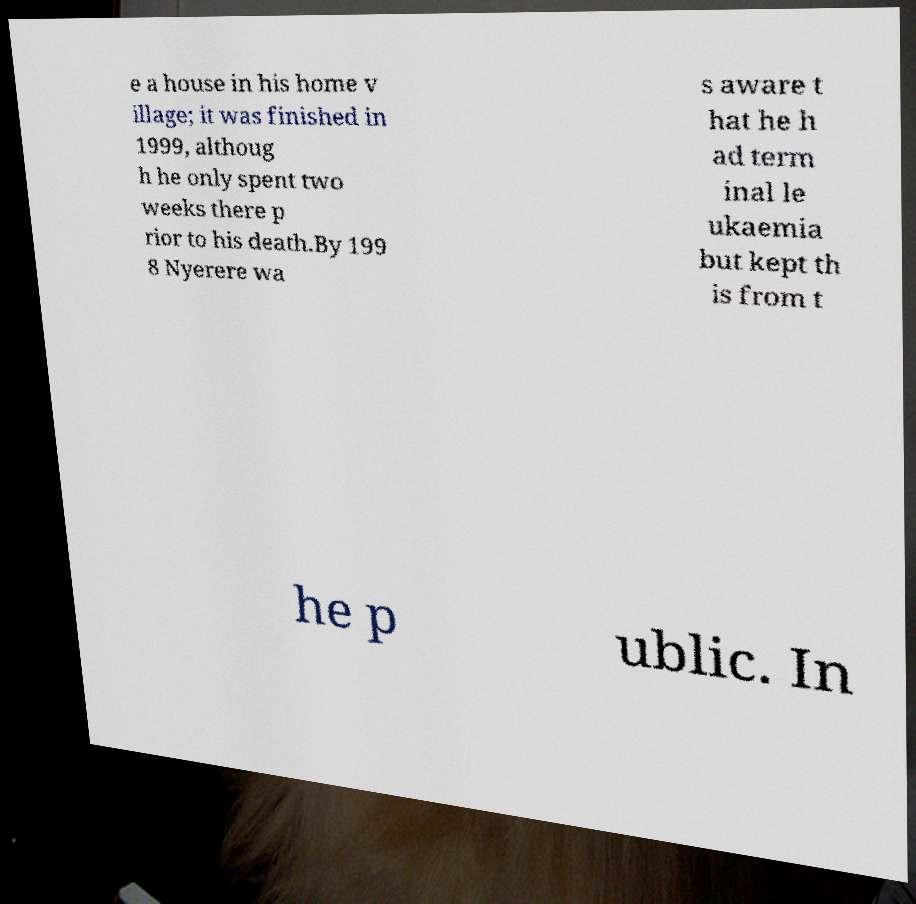Please identify and transcribe the text found in this image. e a house in his home v illage; it was finished in 1999, althoug h he only spent two weeks there p rior to his death.By 199 8 Nyerere wa s aware t hat he h ad term inal le ukaemia but kept th is from t he p ublic. In 